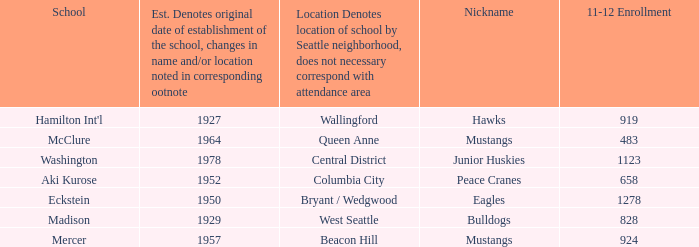Name the minimum 11-12 enrollment for washington school 1123.0. 